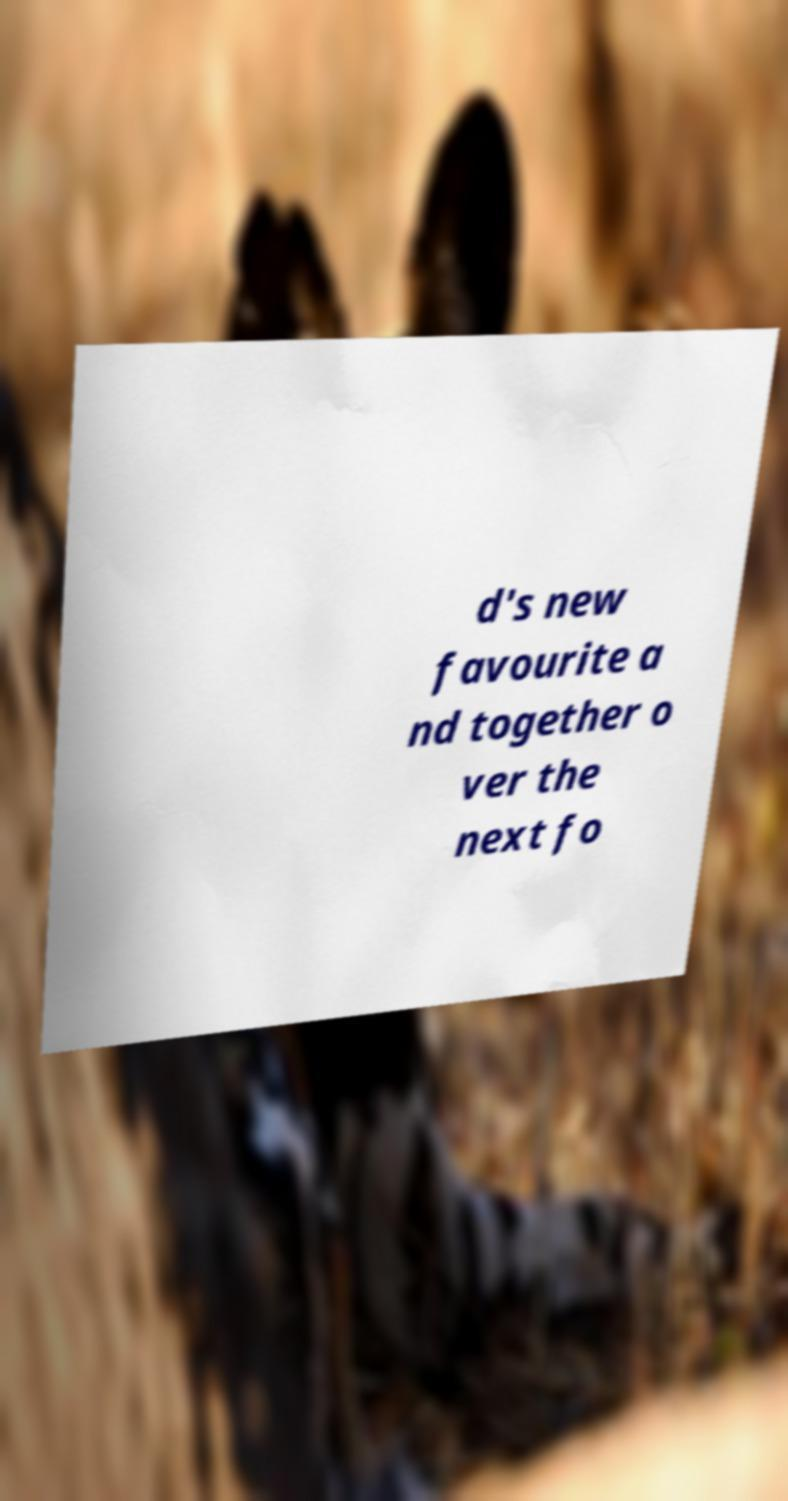I need the written content from this picture converted into text. Can you do that? d's new favourite a nd together o ver the next fo 